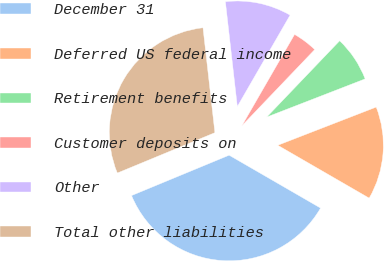Convert chart to OTSL. <chart><loc_0><loc_0><loc_500><loc_500><pie_chart><fcel>December 31<fcel>Deferred US federal income<fcel>Retirement benefits<fcel>Customer deposits on<fcel>Other<fcel>Total other liabilities<nl><fcel>35.41%<fcel>14.23%<fcel>6.97%<fcel>3.81%<fcel>10.13%<fcel>29.44%<nl></chart> 